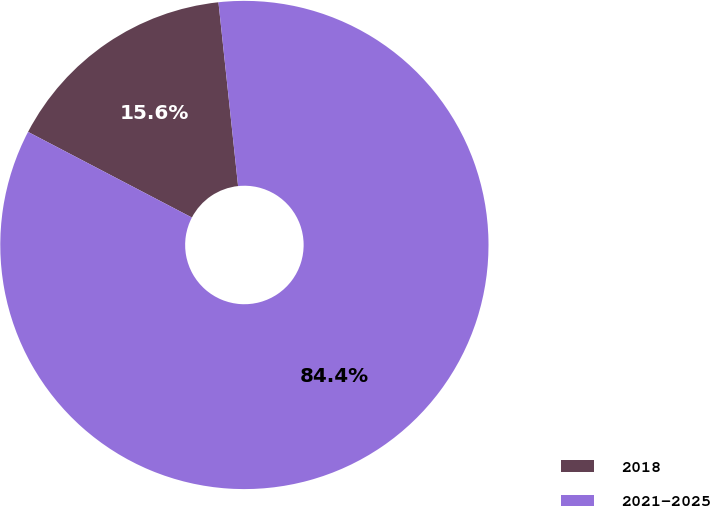Convert chart. <chart><loc_0><loc_0><loc_500><loc_500><pie_chart><fcel>2018<fcel>2021-2025<nl><fcel>15.64%<fcel>84.36%<nl></chart> 